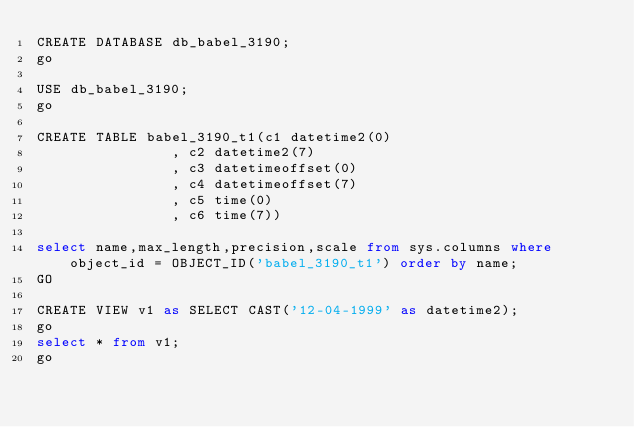<code> <loc_0><loc_0><loc_500><loc_500><_SQL_>CREATE DATABASE db_babel_3190;
go

USE db_babel_3190;
go

CREATE TABLE babel_3190_t1(c1 datetime2(0)
                , c2 datetime2(7)
                , c3 datetimeoffset(0)
                , c4 datetimeoffset(7)
                , c5 time(0)
                , c6 time(7))

select name,max_length,precision,scale from sys.columns where object_id = OBJECT_ID('babel_3190_t1') order by name;
GO

CREATE VIEW v1 as SELECT CAST('12-04-1999' as datetime2);
go
select * from v1;
go
</code> 